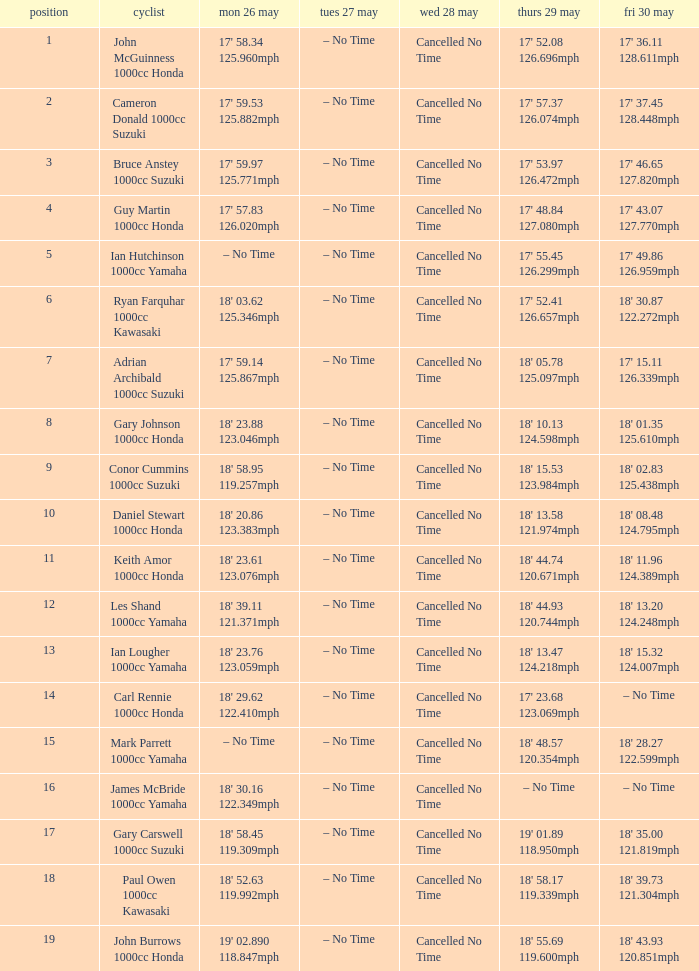What time is mon may 26 and fri may 30 is 18' 28.27 122.599mph? – No Time. Parse the table in full. {'header': ['position', 'cyclist', 'mon 26 may', 'tues 27 may', 'wed 28 may', 'thurs 29 may', 'fri 30 may'], 'rows': [['1', 'John McGuinness 1000cc Honda', "17' 58.34 125.960mph", '– No Time', 'Cancelled No Time', "17' 52.08 126.696mph", "17' 36.11 128.611mph"], ['2', 'Cameron Donald 1000cc Suzuki', "17' 59.53 125.882mph", '– No Time', 'Cancelled No Time', "17' 57.37 126.074mph", "17' 37.45 128.448mph"], ['3', 'Bruce Anstey 1000cc Suzuki', "17' 59.97 125.771mph", '– No Time', 'Cancelled No Time', "17' 53.97 126.472mph", "17' 46.65 127.820mph"], ['4', 'Guy Martin 1000cc Honda', "17' 57.83 126.020mph", '– No Time', 'Cancelled No Time', "17' 48.84 127.080mph", "17' 43.07 127.770mph"], ['5', 'Ian Hutchinson 1000cc Yamaha', '– No Time', '– No Time', 'Cancelled No Time', "17' 55.45 126.299mph", "17' 49.86 126.959mph"], ['6', 'Ryan Farquhar 1000cc Kawasaki', "18' 03.62 125.346mph", '– No Time', 'Cancelled No Time', "17' 52.41 126.657mph", "18' 30.87 122.272mph"], ['7', 'Adrian Archibald 1000cc Suzuki', "17' 59.14 125.867mph", '– No Time', 'Cancelled No Time', "18' 05.78 125.097mph", "17' 15.11 126.339mph"], ['8', 'Gary Johnson 1000cc Honda', "18' 23.88 123.046mph", '– No Time', 'Cancelled No Time', "18' 10.13 124.598mph", "18' 01.35 125.610mph"], ['9', 'Conor Cummins 1000cc Suzuki', "18' 58.95 119.257mph", '– No Time', 'Cancelled No Time', "18' 15.53 123.984mph", "18' 02.83 125.438mph"], ['10', 'Daniel Stewart 1000cc Honda', "18' 20.86 123.383mph", '– No Time', 'Cancelled No Time', "18' 13.58 121.974mph", "18' 08.48 124.795mph"], ['11', 'Keith Amor 1000cc Honda', "18' 23.61 123.076mph", '– No Time', 'Cancelled No Time', "18' 44.74 120.671mph", "18' 11.96 124.389mph"], ['12', 'Les Shand 1000cc Yamaha', "18' 39.11 121.371mph", '– No Time', 'Cancelled No Time', "18' 44.93 120.744mph", "18' 13.20 124.248mph"], ['13', 'Ian Lougher 1000cc Yamaha', "18' 23.76 123.059mph", '– No Time', 'Cancelled No Time', "18' 13.47 124.218mph", "18' 15.32 124.007mph"], ['14', 'Carl Rennie 1000cc Honda', "18' 29.62 122.410mph", '– No Time', 'Cancelled No Time', "17' 23.68 123.069mph", '– No Time'], ['15', 'Mark Parrett 1000cc Yamaha', '– No Time', '– No Time', 'Cancelled No Time', "18' 48.57 120.354mph", "18' 28.27 122.599mph"], ['16', 'James McBride 1000cc Yamaha', "18' 30.16 122.349mph", '– No Time', 'Cancelled No Time', '– No Time', '– No Time'], ['17', 'Gary Carswell 1000cc Suzuki', "18' 58.45 119.309mph", '– No Time', 'Cancelled No Time', "19' 01.89 118.950mph", "18' 35.00 121.819mph"], ['18', 'Paul Owen 1000cc Kawasaki', "18' 52.63 119.992mph", '– No Time', 'Cancelled No Time', "18' 58.17 119.339mph", "18' 39.73 121.304mph"], ['19', 'John Burrows 1000cc Honda', "19' 02.890 118.847mph", '– No Time', 'Cancelled No Time', "18' 55.69 119.600mph", "18' 43.93 120.851mph"]]} 